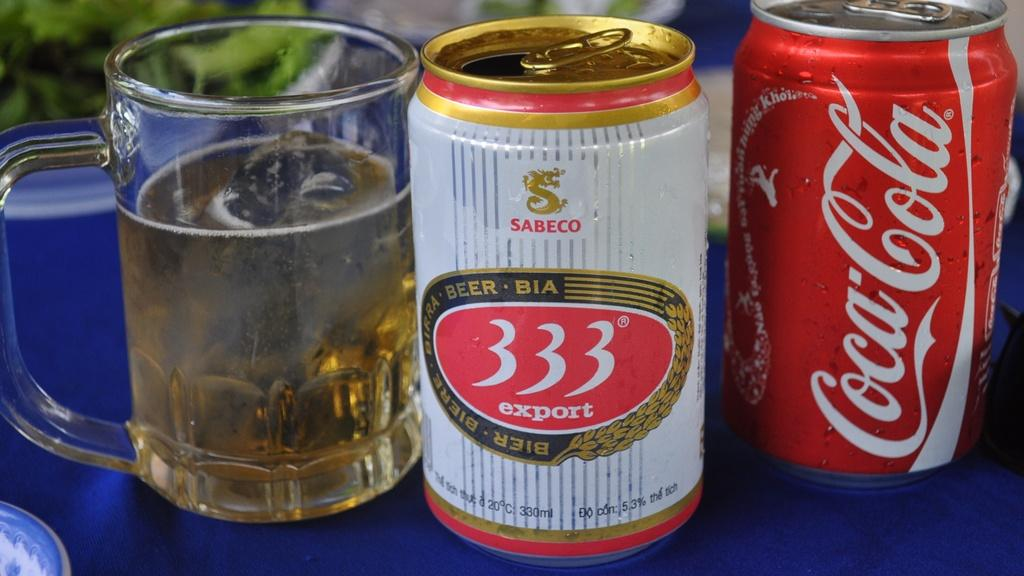<image>
Describe the image concisely. Two cans and two glasses sitting next to one another and one says Coca-Cola on it. 